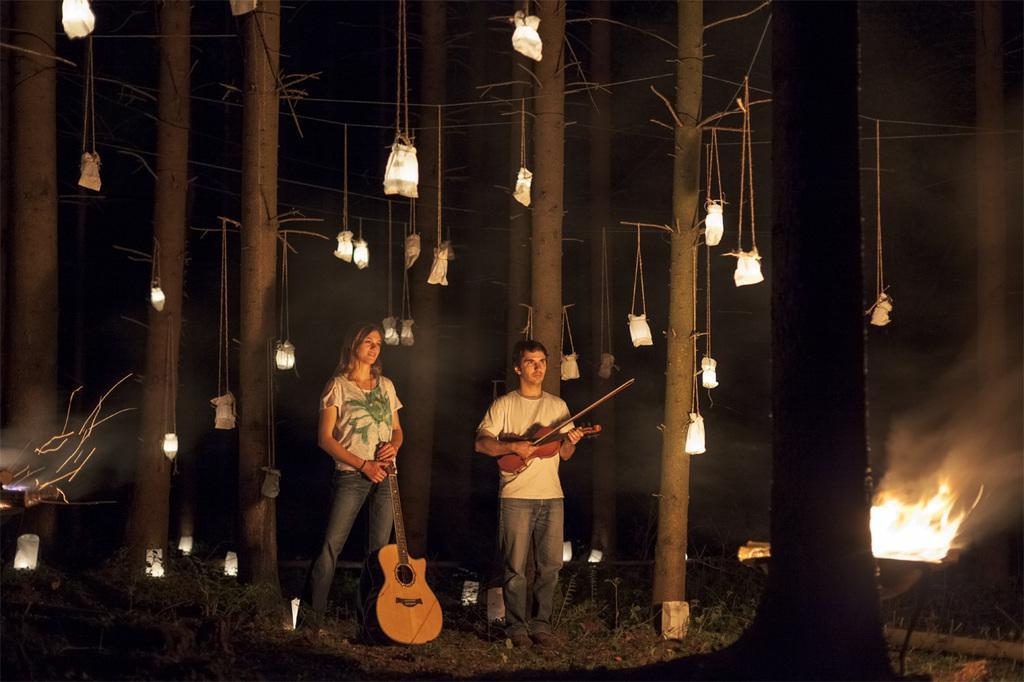How would you summarize this image in a sentence or two? A man and woman are posing to camera. The man is holding a violin and the woman is holding a guitar. 